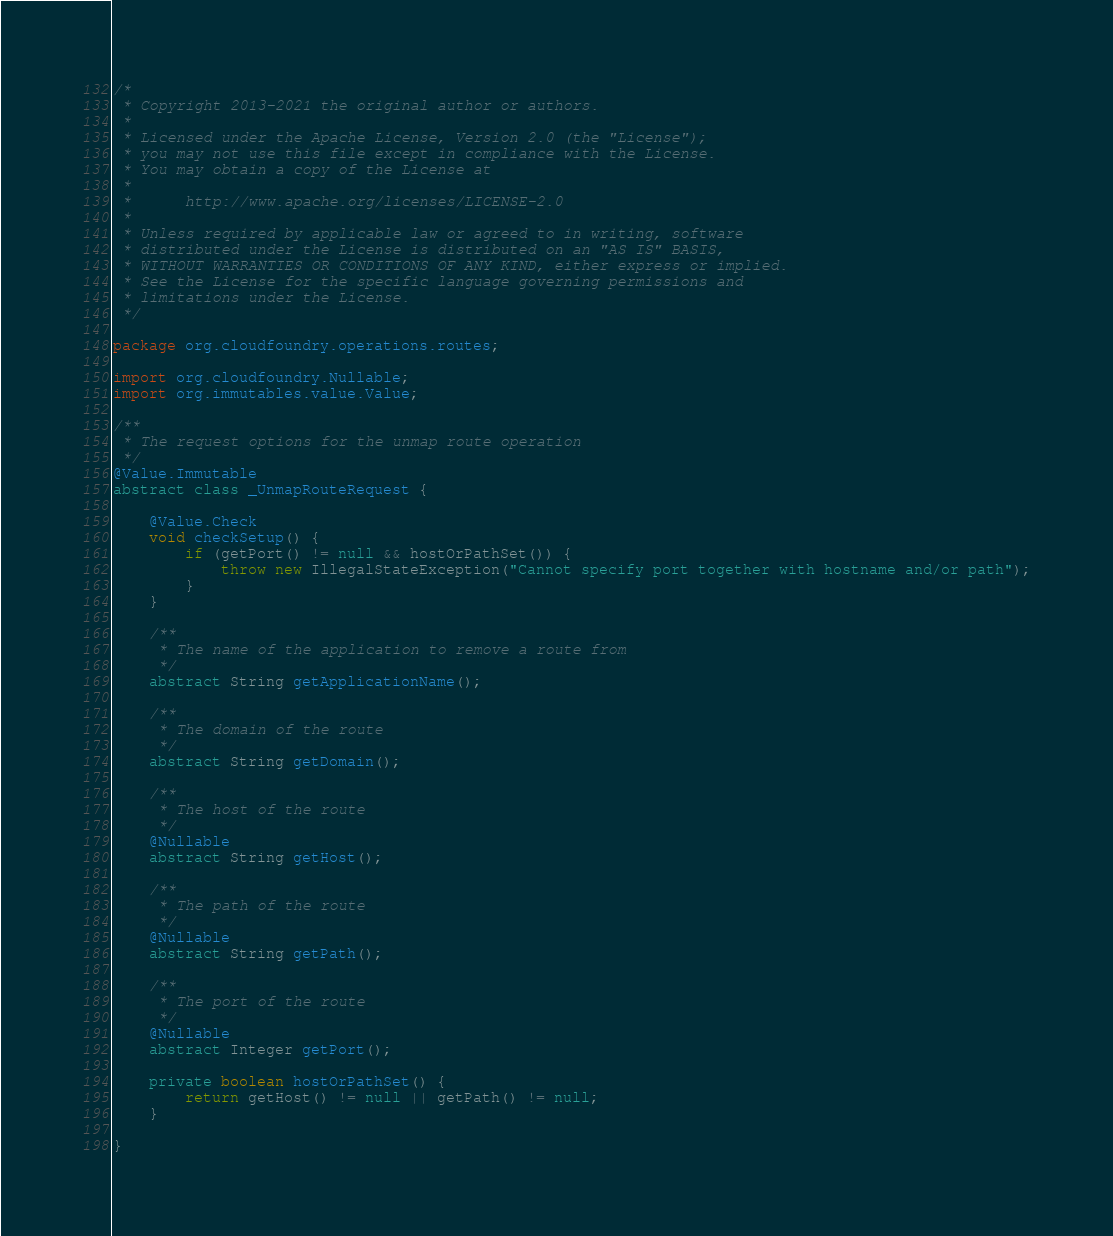<code> <loc_0><loc_0><loc_500><loc_500><_Java_>/*
 * Copyright 2013-2021 the original author or authors.
 *
 * Licensed under the Apache License, Version 2.0 (the "License");
 * you may not use this file except in compliance with the License.
 * You may obtain a copy of the License at
 *
 *      http://www.apache.org/licenses/LICENSE-2.0
 *
 * Unless required by applicable law or agreed to in writing, software
 * distributed under the License is distributed on an "AS IS" BASIS,
 * WITHOUT WARRANTIES OR CONDITIONS OF ANY KIND, either express or implied.
 * See the License for the specific language governing permissions and
 * limitations under the License.
 */

package org.cloudfoundry.operations.routes;

import org.cloudfoundry.Nullable;
import org.immutables.value.Value;

/**
 * The request options for the unmap route operation
 */
@Value.Immutable
abstract class _UnmapRouteRequest {

    @Value.Check
    void checkSetup() {
        if (getPort() != null && hostOrPathSet()) {
            throw new IllegalStateException("Cannot specify port together with hostname and/or path");
        }
    }

    /**
     * The name of the application to remove a route from
     */
    abstract String getApplicationName();

    /**
     * The domain of the route
     */
    abstract String getDomain();

    /**
     * The host of the route
     */
    @Nullable
    abstract String getHost();

    /**
     * The path of the route
     */
    @Nullable
    abstract String getPath();

    /**
     * The port of the route
     */
    @Nullable
    abstract Integer getPort();

    private boolean hostOrPathSet() {
        return getHost() != null || getPath() != null;
    }

}
</code> 